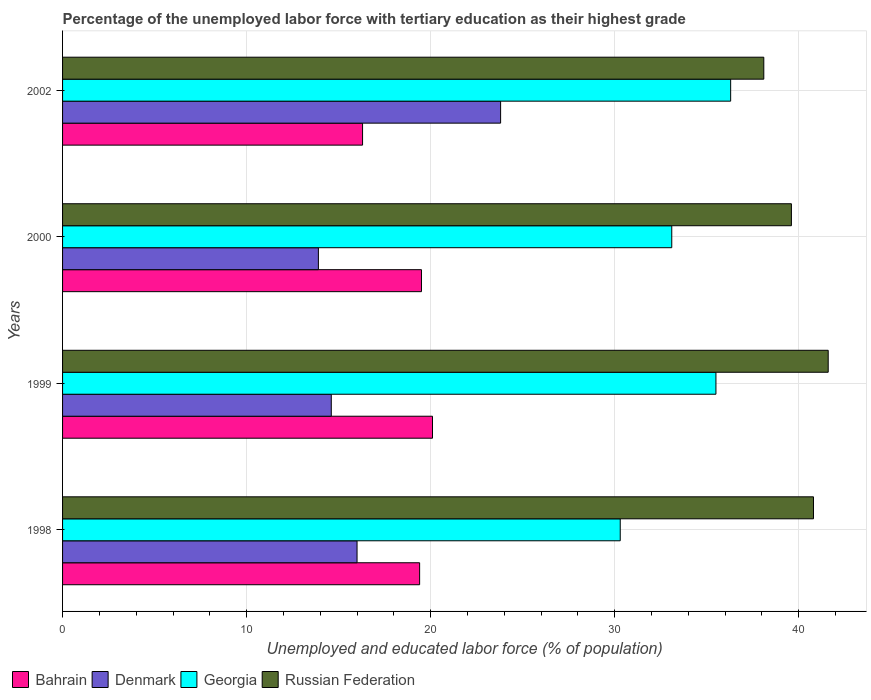How many different coloured bars are there?
Your response must be concise. 4. How many groups of bars are there?
Provide a short and direct response. 4. Are the number of bars per tick equal to the number of legend labels?
Offer a very short reply. Yes. What is the percentage of the unemployed labor force with tertiary education in Georgia in 1998?
Your answer should be compact. 30.3. Across all years, what is the maximum percentage of the unemployed labor force with tertiary education in Georgia?
Your response must be concise. 36.3. Across all years, what is the minimum percentage of the unemployed labor force with tertiary education in Russian Federation?
Provide a short and direct response. 38.1. In which year was the percentage of the unemployed labor force with tertiary education in Georgia maximum?
Your answer should be very brief. 2002. What is the total percentage of the unemployed labor force with tertiary education in Denmark in the graph?
Provide a succinct answer. 68.3. What is the difference between the percentage of the unemployed labor force with tertiary education in Denmark in 1999 and that in 2002?
Offer a very short reply. -9.2. What is the difference between the percentage of the unemployed labor force with tertiary education in Bahrain in 2000 and the percentage of the unemployed labor force with tertiary education in Russian Federation in 1998?
Provide a succinct answer. -21.3. What is the average percentage of the unemployed labor force with tertiary education in Russian Federation per year?
Your response must be concise. 40.02. In the year 1999, what is the difference between the percentage of the unemployed labor force with tertiary education in Denmark and percentage of the unemployed labor force with tertiary education in Georgia?
Keep it short and to the point. -20.9. What is the ratio of the percentage of the unemployed labor force with tertiary education in Denmark in 1998 to that in 2000?
Make the answer very short. 1.15. Is the percentage of the unemployed labor force with tertiary education in Georgia in 1999 less than that in 2002?
Keep it short and to the point. Yes. What is the difference between the highest and the second highest percentage of the unemployed labor force with tertiary education in Denmark?
Provide a succinct answer. 7.8. What is the difference between the highest and the lowest percentage of the unemployed labor force with tertiary education in Georgia?
Keep it short and to the point. 6. Is it the case that in every year, the sum of the percentage of the unemployed labor force with tertiary education in Denmark and percentage of the unemployed labor force with tertiary education in Bahrain is greater than the sum of percentage of the unemployed labor force with tertiary education in Georgia and percentage of the unemployed labor force with tertiary education in Russian Federation?
Make the answer very short. No. What does the 4th bar from the top in 2000 represents?
Your answer should be compact. Bahrain. Is it the case that in every year, the sum of the percentage of the unemployed labor force with tertiary education in Georgia and percentage of the unemployed labor force with tertiary education in Bahrain is greater than the percentage of the unemployed labor force with tertiary education in Russian Federation?
Keep it short and to the point. Yes. How many years are there in the graph?
Give a very brief answer. 4. What is the difference between two consecutive major ticks on the X-axis?
Offer a terse response. 10. Are the values on the major ticks of X-axis written in scientific E-notation?
Ensure brevity in your answer.  No. Does the graph contain any zero values?
Offer a very short reply. No. How are the legend labels stacked?
Your response must be concise. Horizontal. What is the title of the graph?
Your answer should be compact. Percentage of the unemployed labor force with tertiary education as their highest grade. What is the label or title of the X-axis?
Provide a short and direct response. Unemployed and educated labor force (% of population). What is the label or title of the Y-axis?
Make the answer very short. Years. What is the Unemployed and educated labor force (% of population) in Bahrain in 1998?
Your answer should be very brief. 19.4. What is the Unemployed and educated labor force (% of population) of Denmark in 1998?
Keep it short and to the point. 16. What is the Unemployed and educated labor force (% of population) in Georgia in 1998?
Provide a short and direct response. 30.3. What is the Unemployed and educated labor force (% of population) of Russian Federation in 1998?
Your answer should be compact. 40.8. What is the Unemployed and educated labor force (% of population) in Bahrain in 1999?
Your response must be concise. 20.1. What is the Unemployed and educated labor force (% of population) in Denmark in 1999?
Offer a terse response. 14.6. What is the Unemployed and educated labor force (% of population) in Georgia in 1999?
Offer a terse response. 35.5. What is the Unemployed and educated labor force (% of population) in Russian Federation in 1999?
Your answer should be very brief. 41.6. What is the Unemployed and educated labor force (% of population) in Denmark in 2000?
Offer a very short reply. 13.9. What is the Unemployed and educated labor force (% of population) in Georgia in 2000?
Offer a very short reply. 33.1. What is the Unemployed and educated labor force (% of population) in Russian Federation in 2000?
Ensure brevity in your answer.  39.6. What is the Unemployed and educated labor force (% of population) in Bahrain in 2002?
Provide a succinct answer. 16.3. What is the Unemployed and educated labor force (% of population) in Denmark in 2002?
Your answer should be compact. 23.8. What is the Unemployed and educated labor force (% of population) in Georgia in 2002?
Your response must be concise. 36.3. What is the Unemployed and educated labor force (% of population) of Russian Federation in 2002?
Provide a short and direct response. 38.1. Across all years, what is the maximum Unemployed and educated labor force (% of population) in Bahrain?
Provide a short and direct response. 20.1. Across all years, what is the maximum Unemployed and educated labor force (% of population) of Denmark?
Provide a succinct answer. 23.8. Across all years, what is the maximum Unemployed and educated labor force (% of population) in Georgia?
Offer a very short reply. 36.3. Across all years, what is the maximum Unemployed and educated labor force (% of population) in Russian Federation?
Provide a short and direct response. 41.6. Across all years, what is the minimum Unemployed and educated labor force (% of population) of Bahrain?
Offer a very short reply. 16.3. Across all years, what is the minimum Unemployed and educated labor force (% of population) in Denmark?
Your response must be concise. 13.9. Across all years, what is the minimum Unemployed and educated labor force (% of population) in Georgia?
Your answer should be compact. 30.3. Across all years, what is the minimum Unemployed and educated labor force (% of population) in Russian Federation?
Offer a terse response. 38.1. What is the total Unemployed and educated labor force (% of population) of Bahrain in the graph?
Your answer should be compact. 75.3. What is the total Unemployed and educated labor force (% of population) of Denmark in the graph?
Your answer should be compact. 68.3. What is the total Unemployed and educated labor force (% of population) of Georgia in the graph?
Offer a very short reply. 135.2. What is the total Unemployed and educated labor force (% of population) in Russian Federation in the graph?
Make the answer very short. 160.1. What is the difference between the Unemployed and educated labor force (% of population) of Denmark in 1998 and that in 1999?
Offer a terse response. 1.4. What is the difference between the Unemployed and educated labor force (% of population) in Russian Federation in 1998 and that in 1999?
Provide a short and direct response. -0.8. What is the difference between the Unemployed and educated labor force (% of population) of Bahrain in 1998 and that in 2000?
Provide a short and direct response. -0.1. What is the difference between the Unemployed and educated labor force (% of population) in Russian Federation in 1998 and that in 2000?
Your answer should be compact. 1.2. What is the difference between the Unemployed and educated labor force (% of population) in Denmark in 1998 and that in 2002?
Your response must be concise. -7.8. What is the difference between the Unemployed and educated labor force (% of population) in Bahrain in 1999 and that in 2000?
Give a very brief answer. 0.6. What is the difference between the Unemployed and educated labor force (% of population) of Russian Federation in 1999 and that in 2000?
Your answer should be very brief. 2. What is the difference between the Unemployed and educated labor force (% of population) in Denmark in 1999 and that in 2002?
Your answer should be very brief. -9.2. What is the difference between the Unemployed and educated labor force (% of population) of Russian Federation in 1999 and that in 2002?
Offer a terse response. 3.5. What is the difference between the Unemployed and educated labor force (% of population) in Bahrain in 2000 and that in 2002?
Your response must be concise. 3.2. What is the difference between the Unemployed and educated labor force (% of population) in Georgia in 2000 and that in 2002?
Your answer should be compact. -3.2. What is the difference between the Unemployed and educated labor force (% of population) of Russian Federation in 2000 and that in 2002?
Provide a succinct answer. 1.5. What is the difference between the Unemployed and educated labor force (% of population) of Bahrain in 1998 and the Unemployed and educated labor force (% of population) of Georgia in 1999?
Ensure brevity in your answer.  -16.1. What is the difference between the Unemployed and educated labor force (% of population) in Bahrain in 1998 and the Unemployed and educated labor force (% of population) in Russian Federation in 1999?
Provide a short and direct response. -22.2. What is the difference between the Unemployed and educated labor force (% of population) of Denmark in 1998 and the Unemployed and educated labor force (% of population) of Georgia in 1999?
Ensure brevity in your answer.  -19.5. What is the difference between the Unemployed and educated labor force (% of population) of Denmark in 1998 and the Unemployed and educated labor force (% of population) of Russian Federation in 1999?
Make the answer very short. -25.6. What is the difference between the Unemployed and educated labor force (% of population) in Bahrain in 1998 and the Unemployed and educated labor force (% of population) in Georgia in 2000?
Make the answer very short. -13.7. What is the difference between the Unemployed and educated labor force (% of population) of Bahrain in 1998 and the Unemployed and educated labor force (% of population) of Russian Federation in 2000?
Offer a very short reply. -20.2. What is the difference between the Unemployed and educated labor force (% of population) in Denmark in 1998 and the Unemployed and educated labor force (% of population) in Georgia in 2000?
Your answer should be very brief. -17.1. What is the difference between the Unemployed and educated labor force (% of population) of Denmark in 1998 and the Unemployed and educated labor force (% of population) of Russian Federation in 2000?
Offer a terse response. -23.6. What is the difference between the Unemployed and educated labor force (% of population) in Bahrain in 1998 and the Unemployed and educated labor force (% of population) in Georgia in 2002?
Keep it short and to the point. -16.9. What is the difference between the Unemployed and educated labor force (% of population) in Bahrain in 1998 and the Unemployed and educated labor force (% of population) in Russian Federation in 2002?
Offer a terse response. -18.7. What is the difference between the Unemployed and educated labor force (% of population) of Denmark in 1998 and the Unemployed and educated labor force (% of population) of Georgia in 2002?
Offer a terse response. -20.3. What is the difference between the Unemployed and educated labor force (% of population) of Denmark in 1998 and the Unemployed and educated labor force (% of population) of Russian Federation in 2002?
Give a very brief answer. -22.1. What is the difference between the Unemployed and educated labor force (% of population) in Georgia in 1998 and the Unemployed and educated labor force (% of population) in Russian Federation in 2002?
Give a very brief answer. -7.8. What is the difference between the Unemployed and educated labor force (% of population) of Bahrain in 1999 and the Unemployed and educated labor force (% of population) of Denmark in 2000?
Ensure brevity in your answer.  6.2. What is the difference between the Unemployed and educated labor force (% of population) of Bahrain in 1999 and the Unemployed and educated labor force (% of population) of Georgia in 2000?
Keep it short and to the point. -13. What is the difference between the Unemployed and educated labor force (% of population) in Bahrain in 1999 and the Unemployed and educated labor force (% of population) in Russian Federation in 2000?
Keep it short and to the point. -19.5. What is the difference between the Unemployed and educated labor force (% of population) in Denmark in 1999 and the Unemployed and educated labor force (% of population) in Georgia in 2000?
Your answer should be very brief. -18.5. What is the difference between the Unemployed and educated labor force (% of population) in Denmark in 1999 and the Unemployed and educated labor force (% of population) in Russian Federation in 2000?
Your answer should be very brief. -25. What is the difference between the Unemployed and educated labor force (% of population) of Georgia in 1999 and the Unemployed and educated labor force (% of population) of Russian Federation in 2000?
Offer a terse response. -4.1. What is the difference between the Unemployed and educated labor force (% of population) of Bahrain in 1999 and the Unemployed and educated labor force (% of population) of Denmark in 2002?
Provide a succinct answer. -3.7. What is the difference between the Unemployed and educated labor force (% of population) of Bahrain in 1999 and the Unemployed and educated labor force (% of population) of Georgia in 2002?
Keep it short and to the point. -16.2. What is the difference between the Unemployed and educated labor force (% of population) in Denmark in 1999 and the Unemployed and educated labor force (% of population) in Georgia in 2002?
Your response must be concise. -21.7. What is the difference between the Unemployed and educated labor force (% of population) of Denmark in 1999 and the Unemployed and educated labor force (% of population) of Russian Federation in 2002?
Your answer should be compact. -23.5. What is the difference between the Unemployed and educated labor force (% of population) of Bahrain in 2000 and the Unemployed and educated labor force (% of population) of Georgia in 2002?
Ensure brevity in your answer.  -16.8. What is the difference between the Unemployed and educated labor force (% of population) of Bahrain in 2000 and the Unemployed and educated labor force (% of population) of Russian Federation in 2002?
Offer a very short reply. -18.6. What is the difference between the Unemployed and educated labor force (% of population) in Denmark in 2000 and the Unemployed and educated labor force (% of population) in Georgia in 2002?
Provide a short and direct response. -22.4. What is the difference between the Unemployed and educated labor force (% of population) of Denmark in 2000 and the Unemployed and educated labor force (% of population) of Russian Federation in 2002?
Ensure brevity in your answer.  -24.2. What is the difference between the Unemployed and educated labor force (% of population) of Georgia in 2000 and the Unemployed and educated labor force (% of population) of Russian Federation in 2002?
Your answer should be compact. -5. What is the average Unemployed and educated labor force (% of population) in Bahrain per year?
Provide a short and direct response. 18.82. What is the average Unemployed and educated labor force (% of population) in Denmark per year?
Ensure brevity in your answer.  17.07. What is the average Unemployed and educated labor force (% of population) in Georgia per year?
Offer a terse response. 33.8. What is the average Unemployed and educated labor force (% of population) of Russian Federation per year?
Your answer should be very brief. 40.02. In the year 1998, what is the difference between the Unemployed and educated labor force (% of population) of Bahrain and Unemployed and educated labor force (% of population) of Denmark?
Make the answer very short. 3.4. In the year 1998, what is the difference between the Unemployed and educated labor force (% of population) in Bahrain and Unemployed and educated labor force (% of population) in Georgia?
Provide a short and direct response. -10.9. In the year 1998, what is the difference between the Unemployed and educated labor force (% of population) of Bahrain and Unemployed and educated labor force (% of population) of Russian Federation?
Offer a terse response. -21.4. In the year 1998, what is the difference between the Unemployed and educated labor force (% of population) in Denmark and Unemployed and educated labor force (% of population) in Georgia?
Keep it short and to the point. -14.3. In the year 1998, what is the difference between the Unemployed and educated labor force (% of population) in Denmark and Unemployed and educated labor force (% of population) in Russian Federation?
Ensure brevity in your answer.  -24.8. In the year 1999, what is the difference between the Unemployed and educated labor force (% of population) in Bahrain and Unemployed and educated labor force (% of population) in Georgia?
Provide a succinct answer. -15.4. In the year 1999, what is the difference between the Unemployed and educated labor force (% of population) in Bahrain and Unemployed and educated labor force (% of population) in Russian Federation?
Give a very brief answer. -21.5. In the year 1999, what is the difference between the Unemployed and educated labor force (% of population) of Denmark and Unemployed and educated labor force (% of population) of Georgia?
Give a very brief answer. -20.9. In the year 2000, what is the difference between the Unemployed and educated labor force (% of population) of Bahrain and Unemployed and educated labor force (% of population) of Georgia?
Keep it short and to the point. -13.6. In the year 2000, what is the difference between the Unemployed and educated labor force (% of population) in Bahrain and Unemployed and educated labor force (% of population) in Russian Federation?
Give a very brief answer. -20.1. In the year 2000, what is the difference between the Unemployed and educated labor force (% of population) of Denmark and Unemployed and educated labor force (% of population) of Georgia?
Make the answer very short. -19.2. In the year 2000, what is the difference between the Unemployed and educated labor force (% of population) of Denmark and Unemployed and educated labor force (% of population) of Russian Federation?
Give a very brief answer. -25.7. In the year 2002, what is the difference between the Unemployed and educated labor force (% of population) of Bahrain and Unemployed and educated labor force (% of population) of Georgia?
Keep it short and to the point. -20. In the year 2002, what is the difference between the Unemployed and educated labor force (% of population) in Bahrain and Unemployed and educated labor force (% of population) in Russian Federation?
Your response must be concise. -21.8. In the year 2002, what is the difference between the Unemployed and educated labor force (% of population) in Denmark and Unemployed and educated labor force (% of population) in Georgia?
Give a very brief answer. -12.5. In the year 2002, what is the difference between the Unemployed and educated labor force (% of population) in Denmark and Unemployed and educated labor force (% of population) in Russian Federation?
Keep it short and to the point. -14.3. What is the ratio of the Unemployed and educated labor force (% of population) of Bahrain in 1998 to that in 1999?
Your answer should be compact. 0.97. What is the ratio of the Unemployed and educated labor force (% of population) in Denmark in 1998 to that in 1999?
Your answer should be compact. 1.1. What is the ratio of the Unemployed and educated labor force (% of population) in Georgia in 1998 to that in 1999?
Ensure brevity in your answer.  0.85. What is the ratio of the Unemployed and educated labor force (% of population) of Russian Federation in 1998 to that in 1999?
Offer a terse response. 0.98. What is the ratio of the Unemployed and educated labor force (% of population) in Denmark in 1998 to that in 2000?
Keep it short and to the point. 1.15. What is the ratio of the Unemployed and educated labor force (% of population) of Georgia in 1998 to that in 2000?
Offer a very short reply. 0.92. What is the ratio of the Unemployed and educated labor force (% of population) of Russian Federation in 1998 to that in 2000?
Your answer should be compact. 1.03. What is the ratio of the Unemployed and educated labor force (% of population) of Bahrain in 1998 to that in 2002?
Provide a succinct answer. 1.19. What is the ratio of the Unemployed and educated labor force (% of population) in Denmark in 1998 to that in 2002?
Offer a very short reply. 0.67. What is the ratio of the Unemployed and educated labor force (% of population) of Georgia in 1998 to that in 2002?
Give a very brief answer. 0.83. What is the ratio of the Unemployed and educated labor force (% of population) in Russian Federation in 1998 to that in 2002?
Ensure brevity in your answer.  1.07. What is the ratio of the Unemployed and educated labor force (% of population) in Bahrain in 1999 to that in 2000?
Provide a short and direct response. 1.03. What is the ratio of the Unemployed and educated labor force (% of population) in Denmark in 1999 to that in 2000?
Offer a terse response. 1.05. What is the ratio of the Unemployed and educated labor force (% of population) of Georgia in 1999 to that in 2000?
Ensure brevity in your answer.  1.07. What is the ratio of the Unemployed and educated labor force (% of population) in Russian Federation in 1999 to that in 2000?
Your response must be concise. 1.05. What is the ratio of the Unemployed and educated labor force (% of population) of Bahrain in 1999 to that in 2002?
Ensure brevity in your answer.  1.23. What is the ratio of the Unemployed and educated labor force (% of population) in Denmark in 1999 to that in 2002?
Ensure brevity in your answer.  0.61. What is the ratio of the Unemployed and educated labor force (% of population) in Russian Federation in 1999 to that in 2002?
Offer a terse response. 1.09. What is the ratio of the Unemployed and educated labor force (% of population) of Bahrain in 2000 to that in 2002?
Offer a very short reply. 1.2. What is the ratio of the Unemployed and educated labor force (% of population) in Denmark in 2000 to that in 2002?
Provide a succinct answer. 0.58. What is the ratio of the Unemployed and educated labor force (% of population) in Georgia in 2000 to that in 2002?
Provide a succinct answer. 0.91. What is the ratio of the Unemployed and educated labor force (% of population) of Russian Federation in 2000 to that in 2002?
Your answer should be very brief. 1.04. What is the difference between the highest and the second highest Unemployed and educated labor force (% of population) of Denmark?
Ensure brevity in your answer.  7.8. What is the difference between the highest and the second highest Unemployed and educated labor force (% of population) in Russian Federation?
Provide a short and direct response. 0.8. What is the difference between the highest and the lowest Unemployed and educated labor force (% of population) of Denmark?
Give a very brief answer. 9.9. 